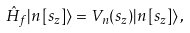<formula> <loc_0><loc_0><loc_500><loc_500>\hat { H } _ { f } | n \left [ s _ { z } \right ] \rangle = V _ { n } ( s _ { z } ) | n \left [ s _ { z } \right ] \rangle \, ,</formula> 